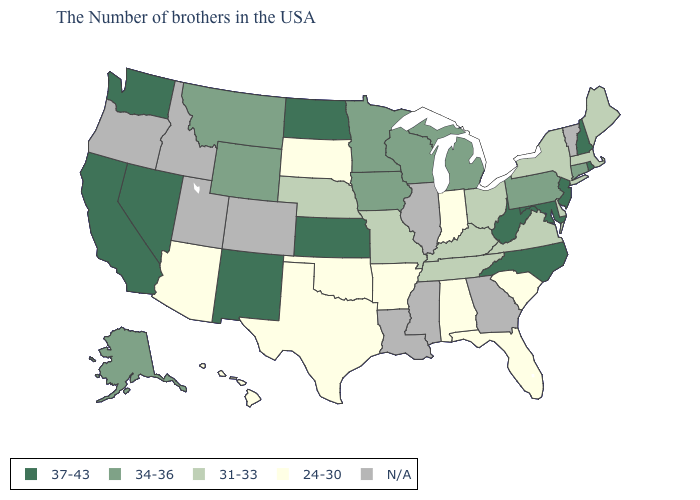What is the lowest value in the USA?
Quick response, please. 24-30. Name the states that have a value in the range 31-33?
Keep it brief. Maine, Massachusetts, New York, Delaware, Virginia, Ohio, Kentucky, Tennessee, Missouri, Nebraska. Which states hav the highest value in the West?
Write a very short answer. New Mexico, Nevada, California, Washington. Is the legend a continuous bar?
Give a very brief answer. No. What is the highest value in the South ?
Short answer required. 37-43. What is the value of Washington?
Quick response, please. 37-43. What is the value of Rhode Island?
Be succinct. 37-43. What is the value of Rhode Island?
Give a very brief answer. 37-43. Name the states that have a value in the range N/A?
Short answer required. Vermont, Georgia, Illinois, Mississippi, Louisiana, Colorado, Utah, Idaho, Oregon. What is the highest value in the USA?
Give a very brief answer. 37-43. Name the states that have a value in the range N/A?
Be succinct. Vermont, Georgia, Illinois, Mississippi, Louisiana, Colorado, Utah, Idaho, Oregon. What is the value of Mississippi?
Give a very brief answer. N/A. Which states have the lowest value in the USA?
Keep it brief. South Carolina, Florida, Indiana, Alabama, Arkansas, Oklahoma, Texas, South Dakota, Arizona, Hawaii. Which states have the lowest value in the West?
Write a very short answer. Arizona, Hawaii. 